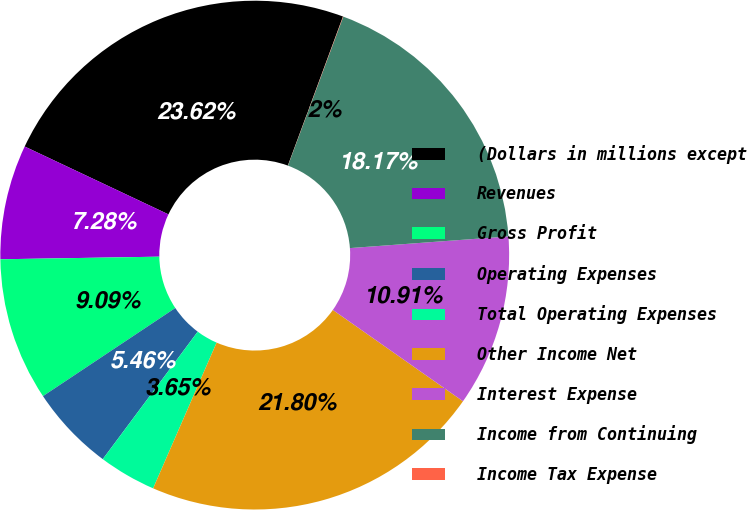Convert chart to OTSL. <chart><loc_0><loc_0><loc_500><loc_500><pie_chart><fcel>(Dollars in millions except<fcel>Revenues<fcel>Gross Profit<fcel>Operating Expenses<fcel>Total Operating Expenses<fcel>Other Income Net<fcel>Interest Expense<fcel>Income from Continuing<fcel>Income Tax Expense<nl><fcel>23.62%<fcel>7.28%<fcel>9.09%<fcel>5.46%<fcel>3.65%<fcel>21.8%<fcel>10.91%<fcel>18.17%<fcel>0.02%<nl></chart> 